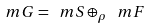<formula> <loc_0><loc_0><loc_500><loc_500>\ m G = \ m S \oplus _ { \rho } \ m F</formula> 